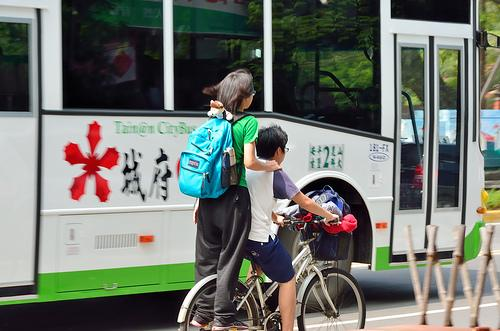Describe the different tasks happening in the bus and outside. Inside the bus, people may be sitting or standing by the doors or windows. Outside, the bus is driving down the street on a busy road. Describe the clothing of the people in the picture. A girl in a green shirt and black sweats is standing on the back of the bicycle, and a boy is wearing a white shirt, blue shorts, and has black hair.  Identify the type of transportation present in the picture. There are two types of transportation present: a bicycle and a bus. Please provide a brief description of the image and its significant elements. The image shows a man riding a white bicycle with two kids standing on its back. There is also a big bus on the road, a blue backpack, a bus window, and bicycles wheels. Describe any noteworthy interactions between the objects identified in the image. A man rides the white bicycle while two kids stand on its back, and a large bus moves down the road near them, with all these elements creating a lively and active street scene. What animal is in the image, and describe its interaction with the other elements in the picture. There is no animal present in the image. Please give a sentiment analysis of the image. The image has a positive sentiment, with people enjoying a bike ride and a bus traveling down a busy street. Are there any activities involving the bicycle, and if so, what are they doing? Yes, there are activities involving the bicycle. A man is riding the bicycle, and two kids are standing on the back of it. Count the number of wheels present in the image. There are six wheels in total; four from the bus, and two from the bicycle. Mention any distinctive color or symbol you can observe in the image. There is a red symbol on the bus, and a girl is wearing a green shirt with multicolored sneakers. 